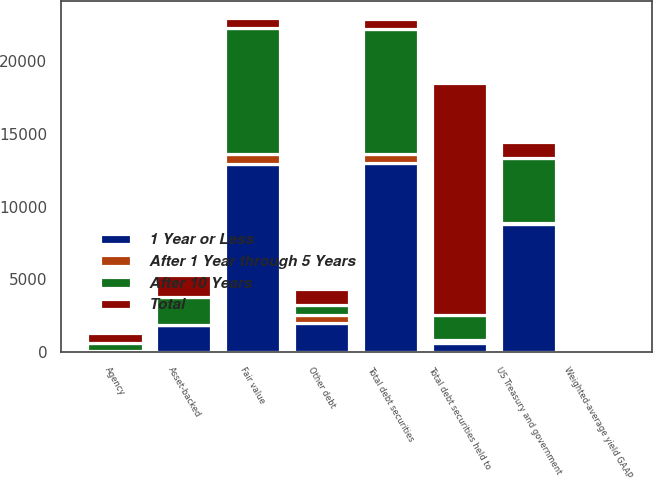Convert chart to OTSL. <chart><loc_0><loc_0><loc_500><loc_500><stacked_bar_chart><ecel><fcel>US Treasury and government<fcel>Agency<fcel>Asset-backed<fcel>Other debt<fcel>Total debt securities<fcel>Fair value<fcel>Weighted-average yield GAAP<fcel>Total debt securities held to<nl><fcel>After 1 Year through 5 Years<fcel>85<fcel>3<fcel>13<fcel>521<fcel>624<fcel>626<fcel>2.73<fcel>221<nl><fcel>1 Year or Less<fcel>8780<fcel>45<fcel>1846<fcel>2032<fcel>12962<fcel>12958<fcel>2.12<fcel>638<nl><fcel>After 10 Years<fcel>4449<fcel>561<fcel>1897<fcel>670<fcel>8652<fcel>8695<fcel>2.29<fcel>1695<nl><fcel>Total<fcel>1118<fcel>670<fcel>1575<fcel>1099<fcel>670<fcel>670<fcel>2.97<fcel>15959<nl></chart> 